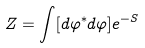Convert formula to latex. <formula><loc_0><loc_0><loc_500><loc_500>Z = \int [ d \varphi ^ { * } d \varphi ] e ^ { - S }</formula> 